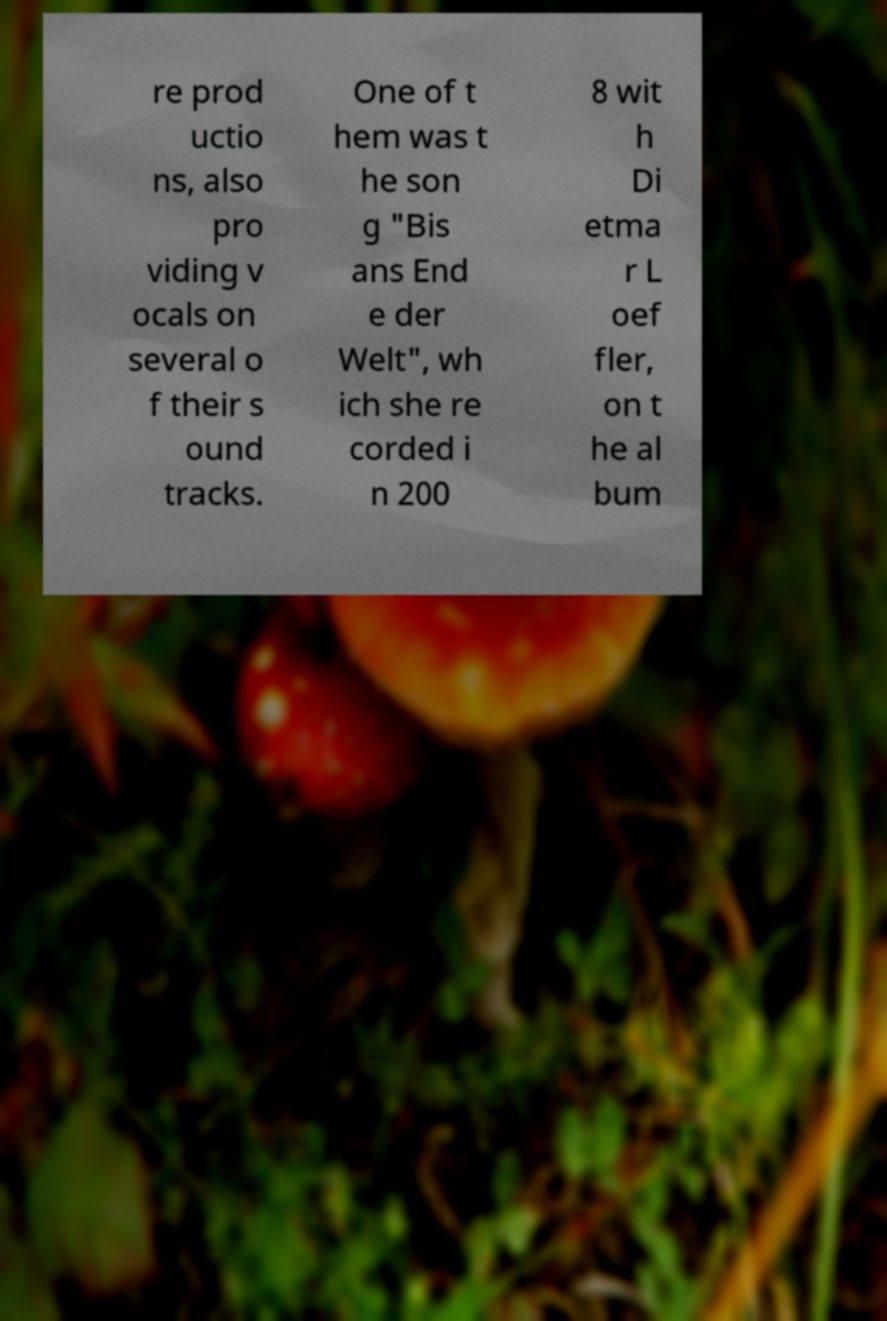I need the written content from this picture converted into text. Can you do that? re prod uctio ns, also pro viding v ocals on several o f their s ound tracks. One of t hem was t he son g "Bis ans End e der Welt", wh ich she re corded i n 200 8 wit h Di etma r L oef fler, on t he al bum 